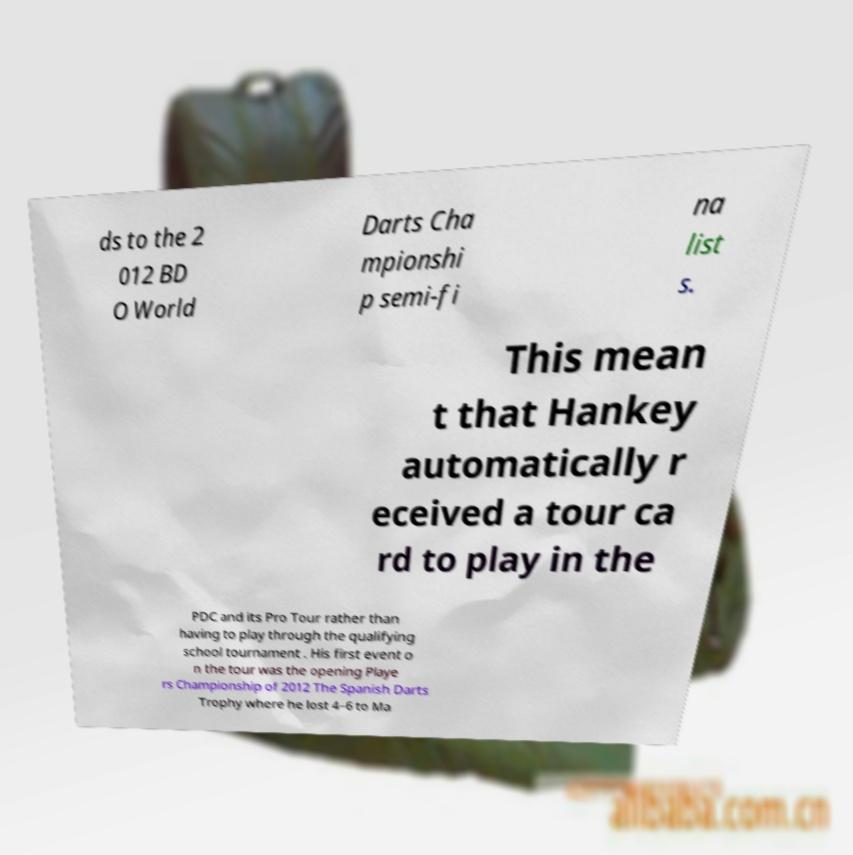There's text embedded in this image that I need extracted. Can you transcribe it verbatim? ds to the 2 012 BD O World Darts Cha mpionshi p semi-fi na list s. This mean t that Hankey automatically r eceived a tour ca rd to play in the PDC and its Pro Tour rather than having to play through the qualifying school tournament . His first event o n the tour was the opening Playe rs Championship of 2012 The Spanish Darts Trophy where he lost 4–6 to Ma 